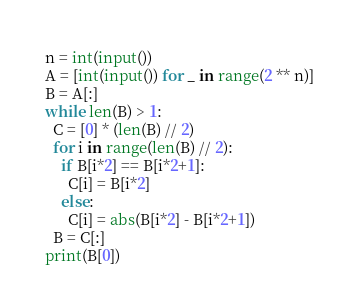<code> <loc_0><loc_0><loc_500><loc_500><_Python_>n = int(input())
A = [int(input()) for _ in range(2 ** n)]
B = A[:]
while len(B) > 1:
  C = [0] * (len(B) // 2)
  for i in range(len(B) // 2):
    if B[i*2] == B[i*2+1]:
      C[i] = B[i*2]
    else:
      C[i] = abs(B[i*2] - B[i*2+1])
  B = C[:]
print(B[0])</code> 